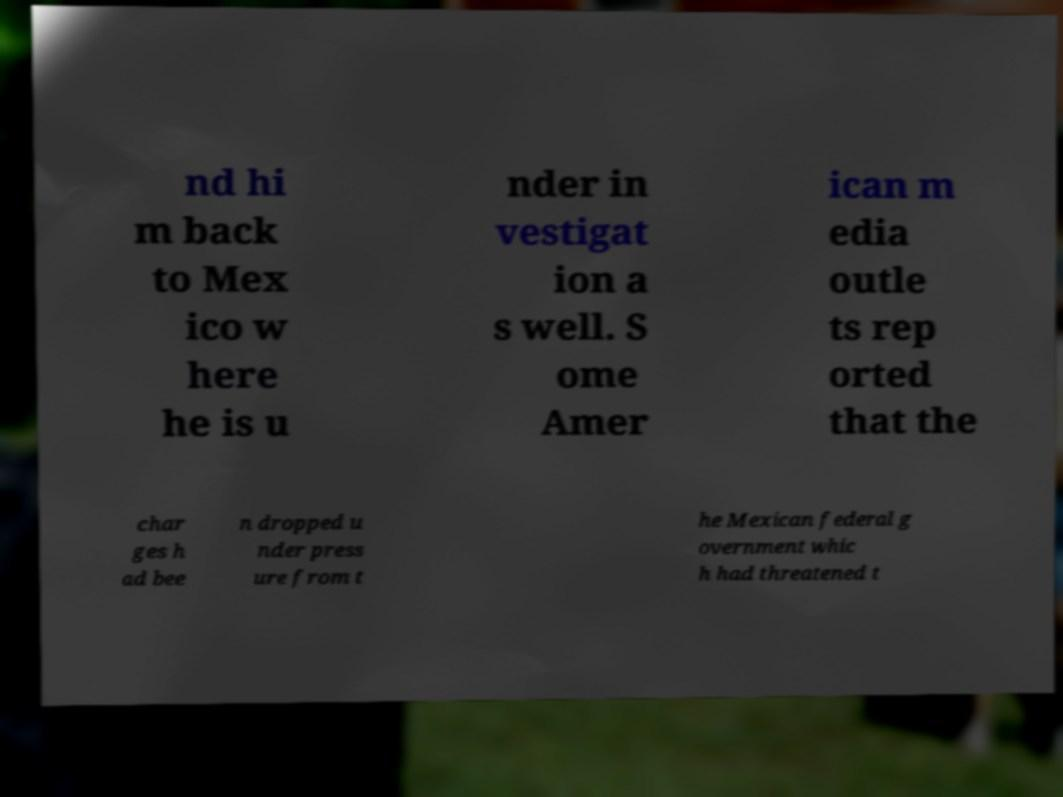For documentation purposes, I need the text within this image transcribed. Could you provide that? nd hi m back to Mex ico w here he is u nder in vestigat ion a s well. S ome Amer ican m edia outle ts rep orted that the char ges h ad bee n dropped u nder press ure from t he Mexican federal g overnment whic h had threatened t 